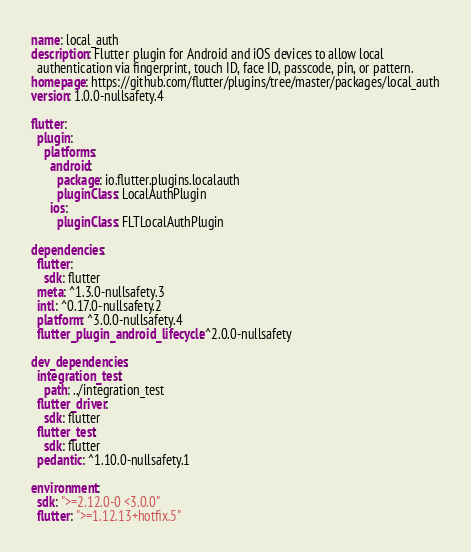<code> <loc_0><loc_0><loc_500><loc_500><_YAML_>name: local_auth
description: Flutter plugin for Android and iOS devices to allow local
  authentication via fingerprint, touch ID, face ID, passcode, pin, or pattern.
homepage: https://github.com/flutter/plugins/tree/master/packages/local_auth
version: 1.0.0-nullsafety.4

flutter:
  plugin:
    platforms:
      android:
        package: io.flutter.plugins.localauth
        pluginClass: LocalAuthPlugin
      ios:
        pluginClass: FLTLocalAuthPlugin

dependencies:
  flutter:
    sdk: flutter
  meta: ^1.3.0-nullsafety.3
  intl: ^0.17.0-nullsafety.2
  platform: ^3.0.0-nullsafety.4
  flutter_plugin_android_lifecycle: ^2.0.0-nullsafety

dev_dependencies:
  integration_test:
    path: ../integration_test
  flutter_driver:
    sdk: flutter
  flutter_test:
    sdk: flutter
  pedantic: ^1.10.0-nullsafety.1

environment:
  sdk: ">=2.12.0-0 <3.0.0"
  flutter: ">=1.12.13+hotfix.5"
</code> 